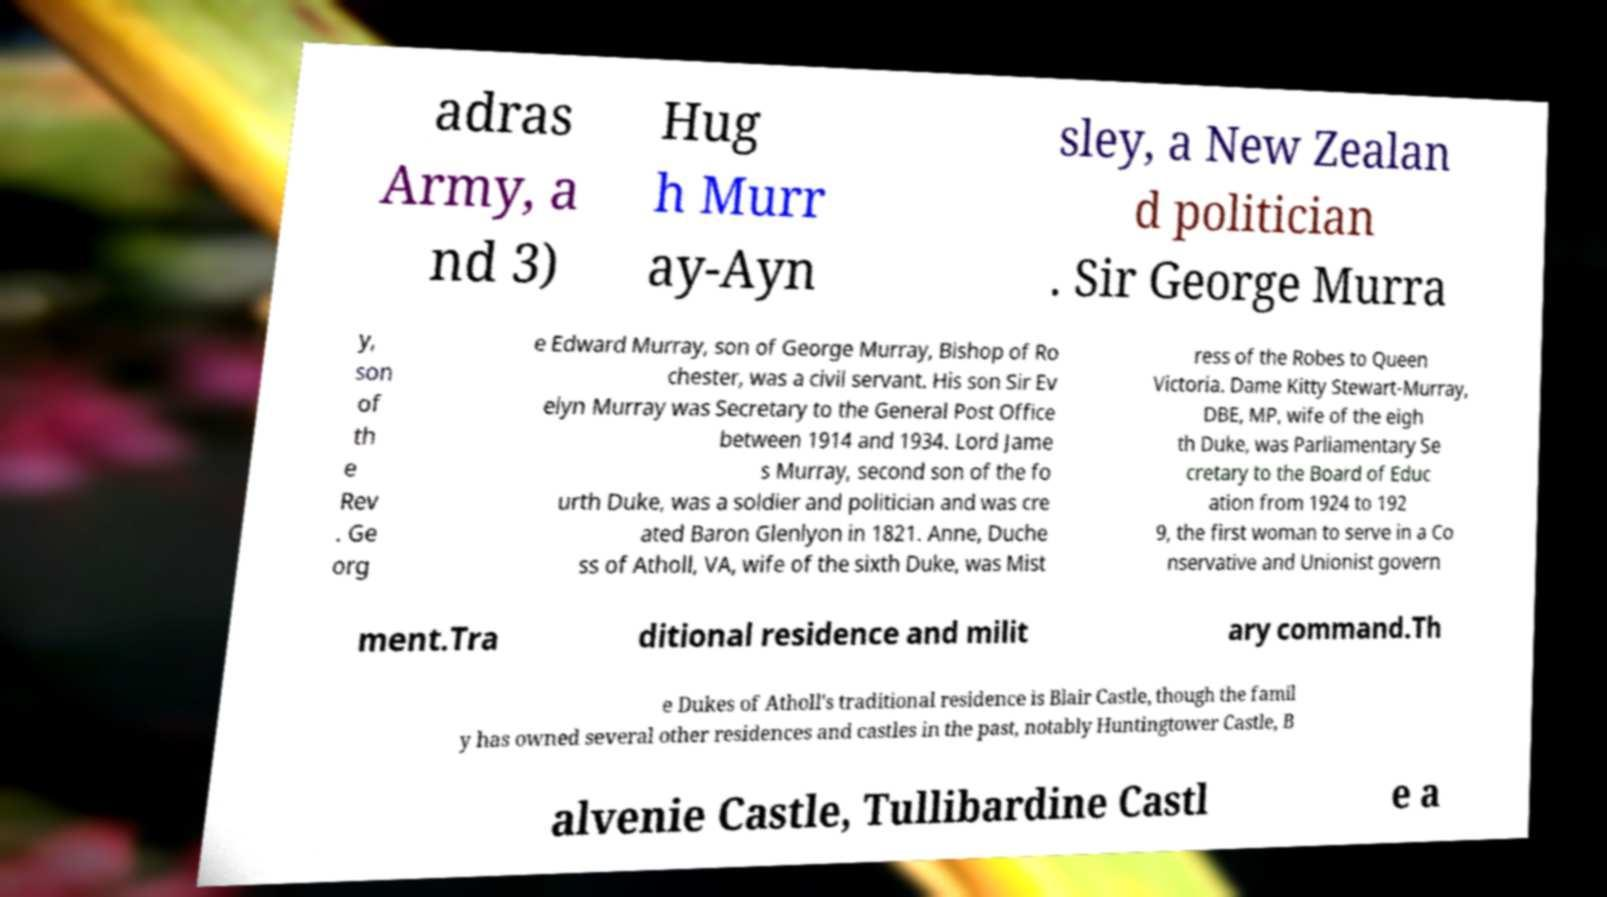Could you extract and type out the text from this image? adras Army, a nd 3) Hug h Murr ay-Ayn sley, a New Zealan d politician . Sir George Murra y, son of th e Rev . Ge org e Edward Murray, son of George Murray, Bishop of Ro chester, was a civil servant. His son Sir Ev elyn Murray was Secretary to the General Post Office between 1914 and 1934. Lord Jame s Murray, second son of the fo urth Duke, was a soldier and politician and was cre ated Baron Glenlyon in 1821. Anne, Duche ss of Atholl, VA, wife of the sixth Duke, was Mist ress of the Robes to Queen Victoria. Dame Kitty Stewart-Murray, DBE, MP, wife of the eigh th Duke, was Parliamentary Se cretary to the Board of Educ ation from 1924 to 192 9, the first woman to serve in a Co nservative and Unionist govern ment.Tra ditional residence and milit ary command.Th e Dukes of Atholl's traditional residence is Blair Castle, though the famil y has owned several other residences and castles in the past, notably Huntingtower Castle, B alvenie Castle, Tullibardine Castl e a 